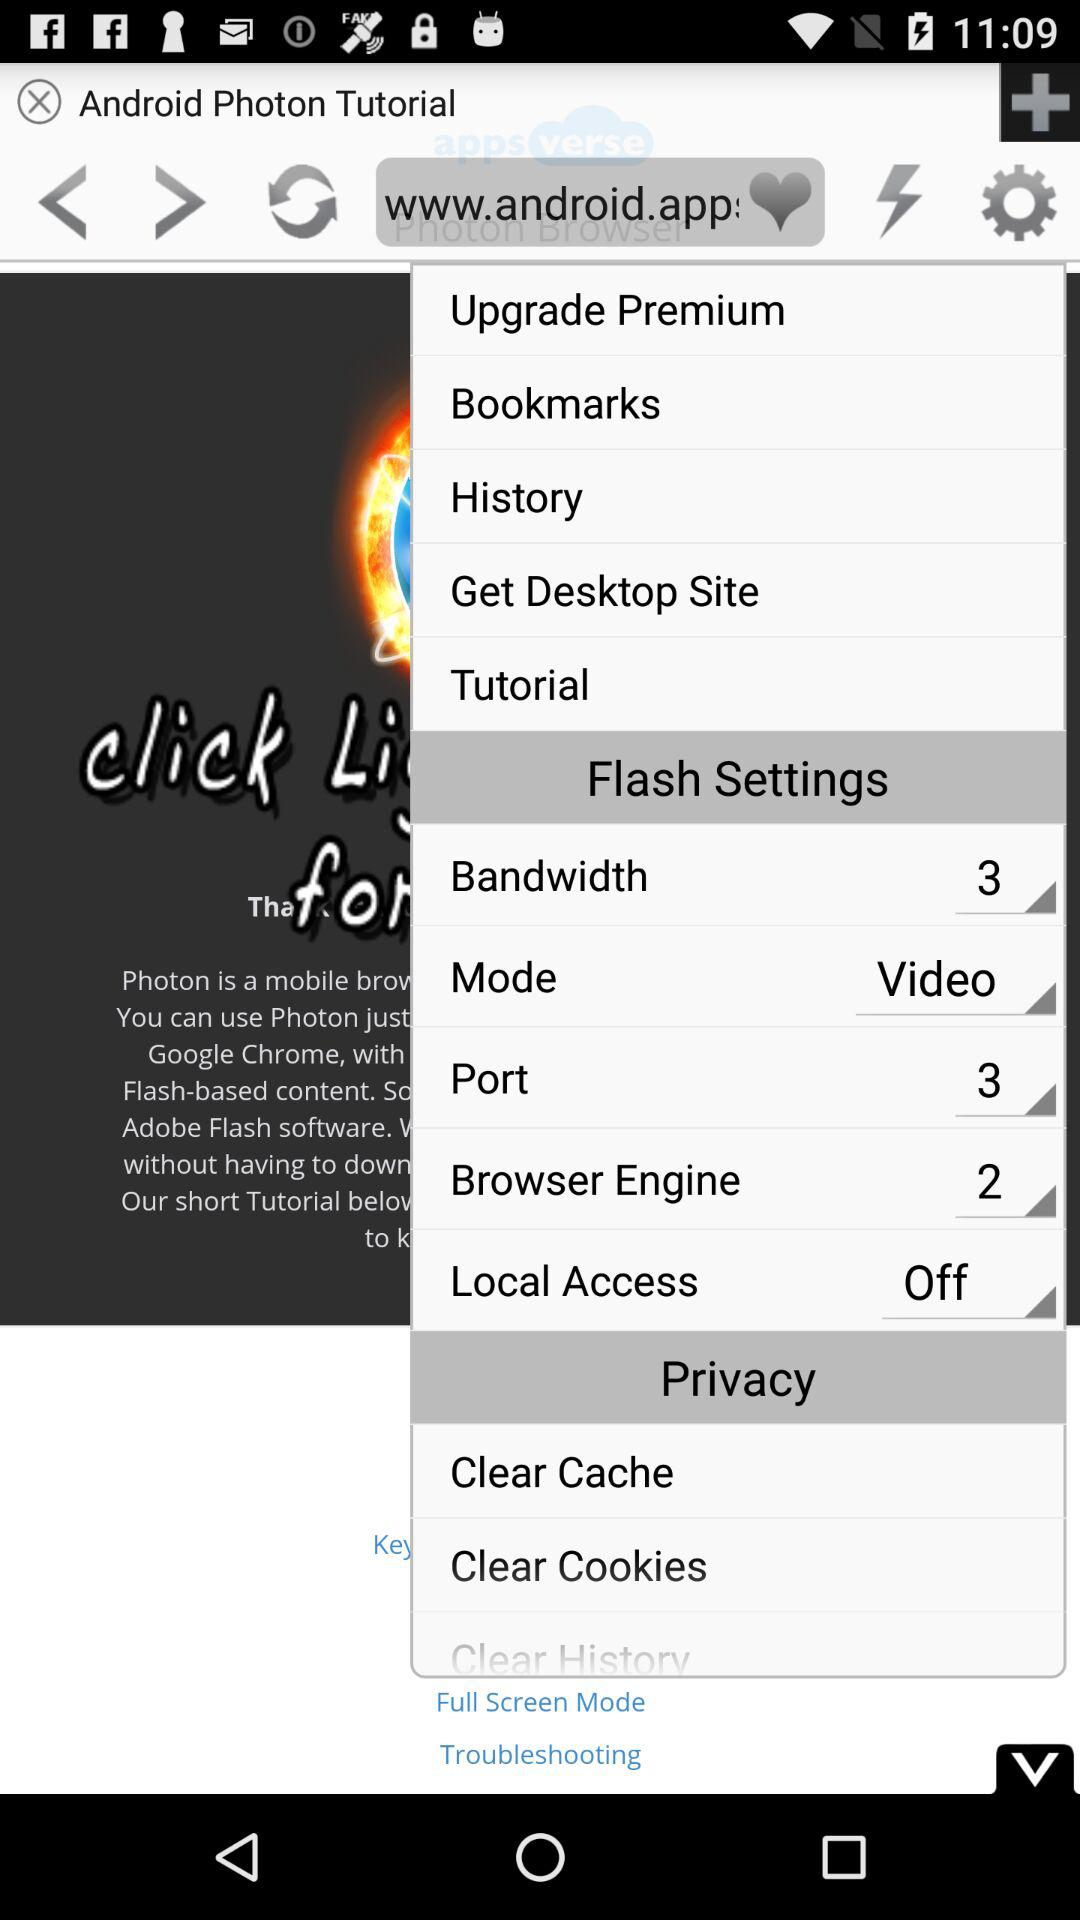What is the status of "Local Access"? The status is "off". 